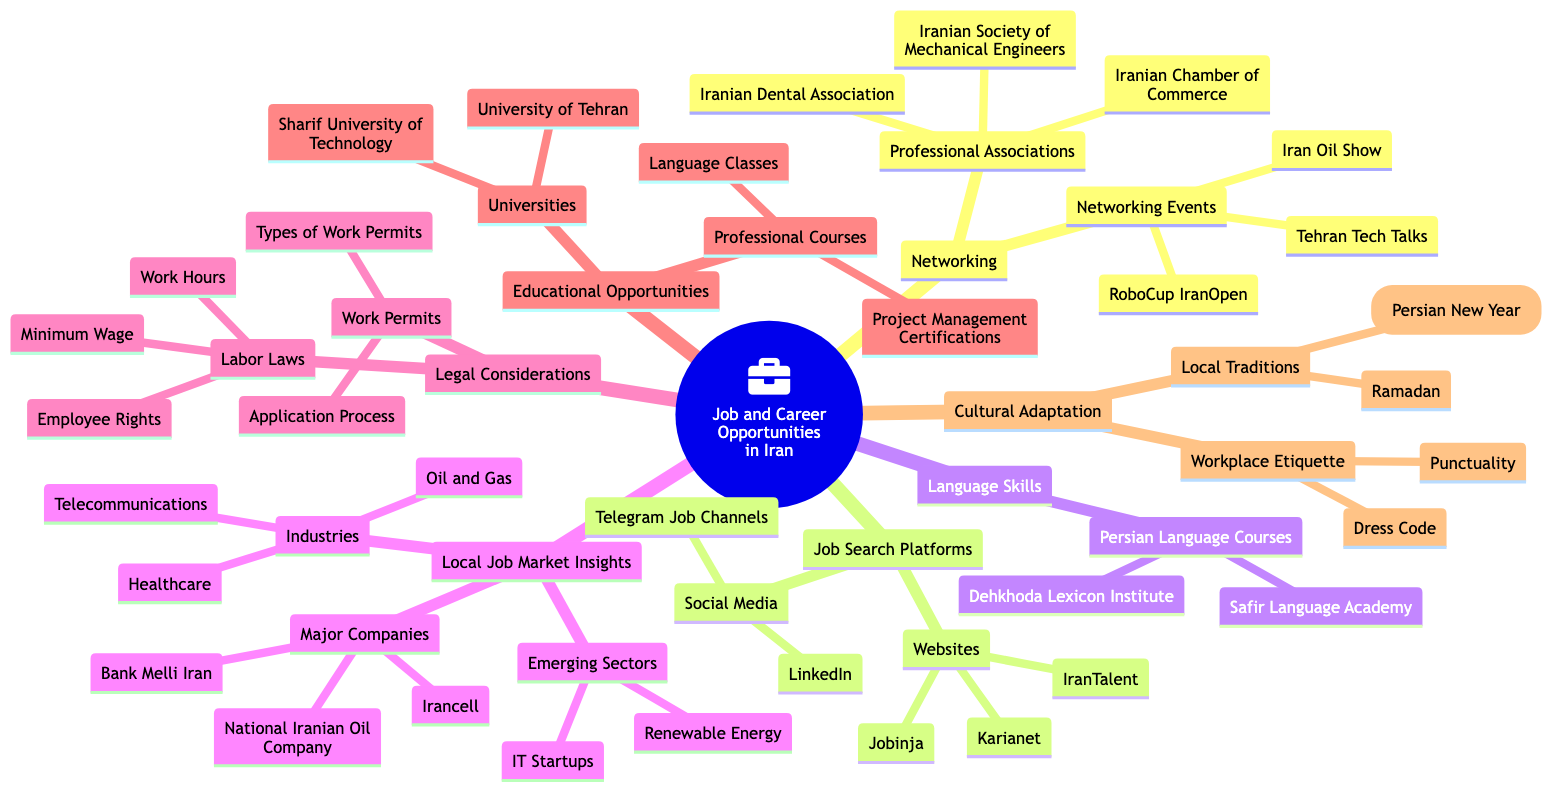What are the major companies listed under Local Job Market Insights? The Local Job Market Insights node has a subnode called Major Companies. Under this subnode, three specific companies are listed: National Iranian Oil Company, Irancell, and Bank Melli Iran.
Answer: National Iranian Oil Company, Irancell, Bank Melli Iran How many professional associations are mentioned in the Networking section? The Networking section has a subnode called Professional Associations, which lists three specific associations: Iranian Chamber of Commerce, Iranian Society of Mechanical Engineers, and Iranian Dental Association. Thus, we count them to find the total number.
Answer: 3 What is one of the emerging sectors in the Local Job Market Insights? Under the Local Job Market Insights node, there is a subnode called Emerging Sectors. This mentions two sectors: Renewable Energy and IT Startups. Since the question asks for one, we can provide any of them as an answer.
Answer: Renewable Energy Which language courses are offered in the Language Skills section? The Language Skills section has a subnode called Persian Language Courses, which includes two courses: Dehkhoda Lexicon Institute and Safir Language Academy. The question is looking for the courses offered, so we can list either of them as an answer.
Answer: Dehkhoda Lexicon Institute What types of legal considerations are included in the diagram? The Legal Considerations node consists of two main subnodes: Work Permits and Labor Laws. To answer the question, we can summarize the types mentioned in both of these categories. The Work Permits subnode discusses Types of Work Permits and Application Process, while the Labor Laws subnode discusses Minimum Wage, Work Hours, and Employee Rights. Hence, they represent the legal considerations outlined.
Answer: Work Permits, Labor Laws What is an example of a Networking Event? Within the Networking node, there is a subnode called Networking Events, which provides a list of specific events including Tehran Tech Talks, Iran Oil Show, and RoboCup IranOpen. Since the question asks for an example, we can choose any of the events listed.
Answer: Tehran Tech Talks 